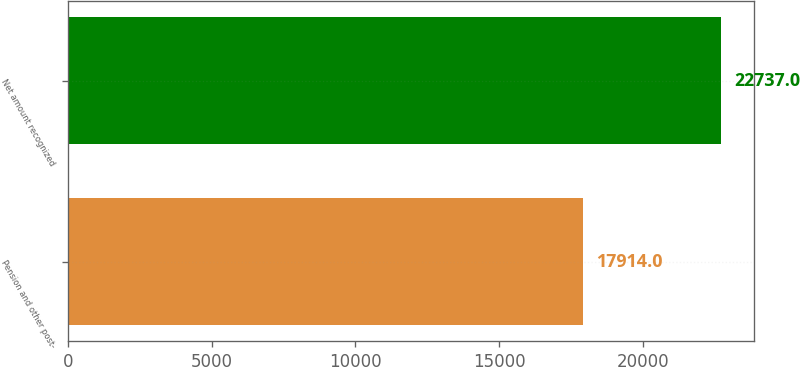Convert chart to OTSL. <chart><loc_0><loc_0><loc_500><loc_500><bar_chart><fcel>Pension and other post-<fcel>Net amount recognized<nl><fcel>17914<fcel>22737<nl></chart> 